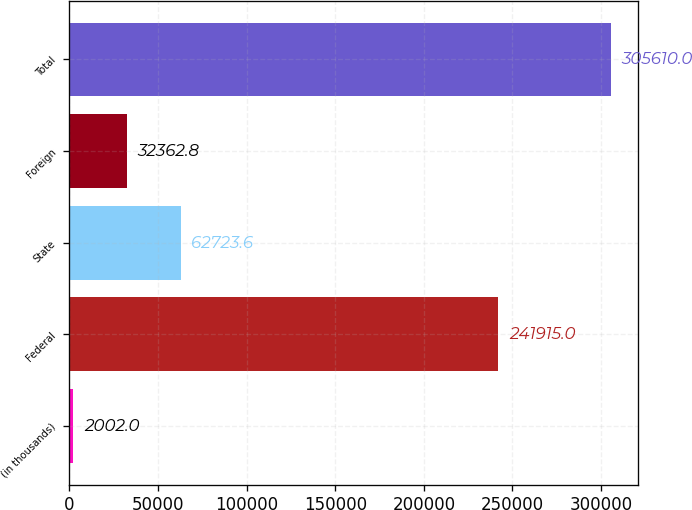Convert chart to OTSL. <chart><loc_0><loc_0><loc_500><loc_500><bar_chart><fcel>(in thousands)<fcel>Federal<fcel>State<fcel>Foreign<fcel>Total<nl><fcel>2002<fcel>241915<fcel>62723.6<fcel>32362.8<fcel>305610<nl></chart> 